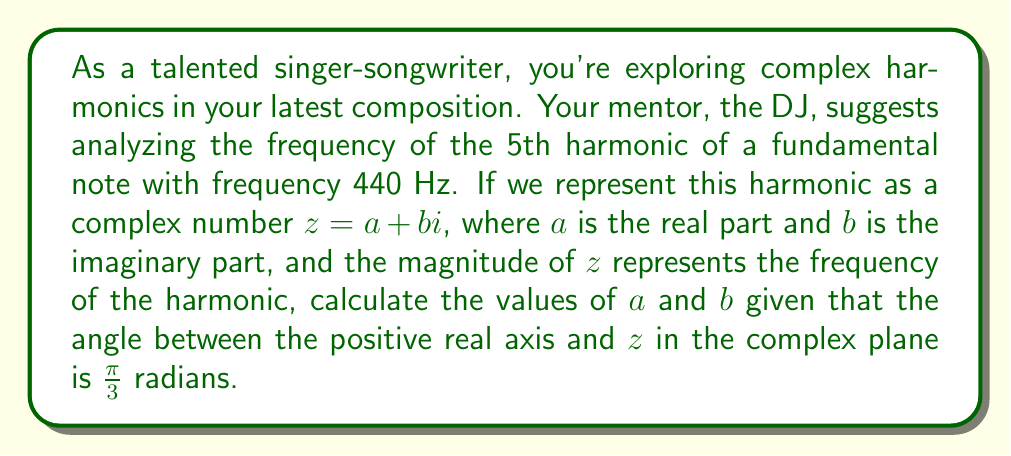Provide a solution to this math problem. Let's approach this step-by-step:

1) The frequency of the 5th harmonic is 5 times the fundamental frequency:
   $$f_5 = 5 \times 440 \text{ Hz} = 2200 \text{ Hz}$$

2) This frequency corresponds to the magnitude of our complex number $z$. In polar form:
   $$|z| = 2200$$

3) We're given that the angle between the positive real axis and $z$ is $\frac{\pi}{3}$ radians.

4) To find $a$ and $b$, we can use the polar to rectangular conversion formulas:
   $$a = |z| \cos(\theta)$$
   $$b = |z| \sin(\theta)$$

   where $\theta = \frac{\pi}{3}$

5) Calculating $a$:
   $$a = 2200 \cos(\frac{\pi}{3}) = 2200 \times \frac{1}{2} = 1100$$

6) Calculating $b$:
   $$b = 2200 \sin(\frac{\pi}{3}) = 2200 \times \frac{\sqrt{3}}{2} = 1100\sqrt{3}$$

Therefore, our complex number $z$ representing the 5th harmonic is:
$$z = 1100 + 1100\sqrt{3}i$$
Answer: $a = 1100$, $b = 1100\sqrt{3}$ 